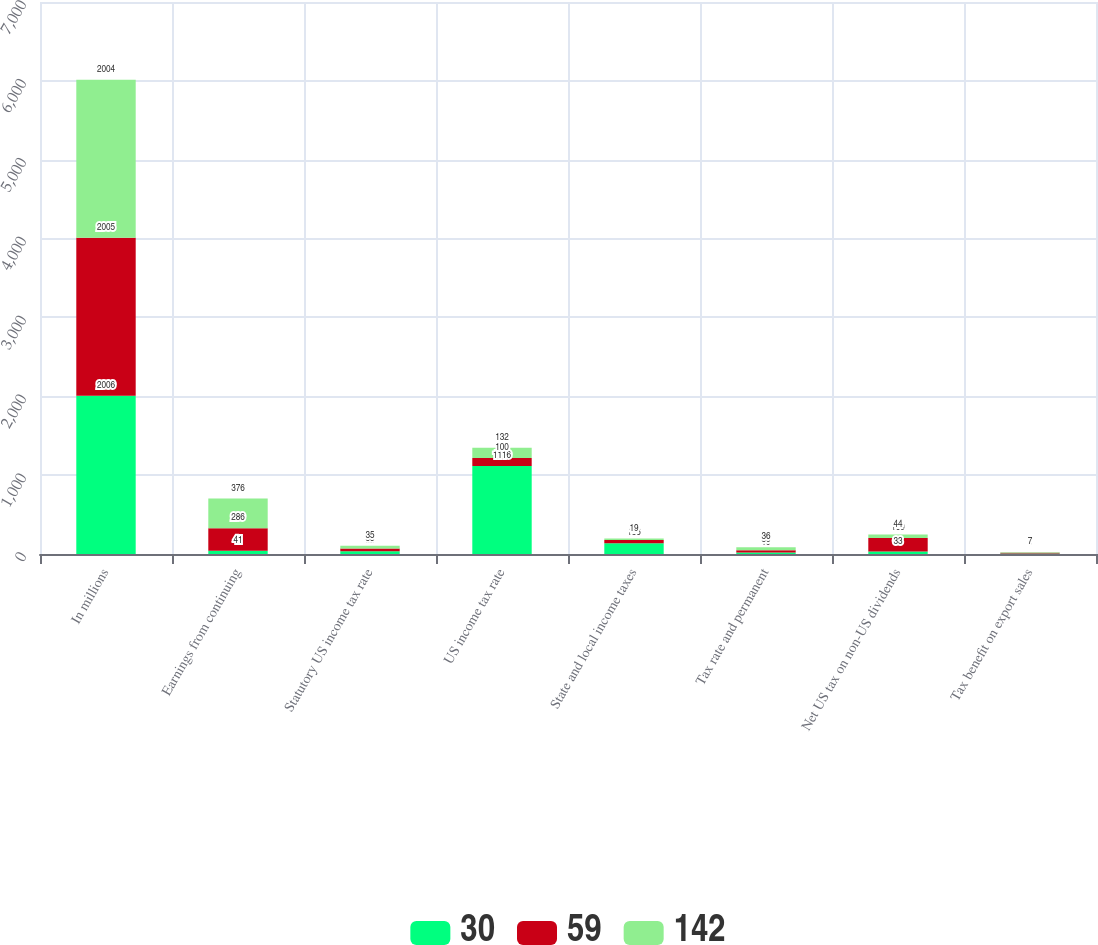Convert chart. <chart><loc_0><loc_0><loc_500><loc_500><stacked_bar_chart><ecel><fcel>In millions<fcel>Earnings from continuing<fcel>Statutory US income tax rate<fcel>US income tax rate<fcel>State and local income taxes<fcel>Tax rate and permanent<fcel>Net US tax on non-US dividends<fcel>Tax benefit on export sales<nl><fcel>30<fcel>2006<fcel>41<fcel>35<fcel>1116<fcel>136<fcel>19<fcel>33<fcel>6<nl><fcel>59<fcel>2005<fcel>286<fcel>35<fcel>100<fcel>41<fcel>30<fcel>169<fcel>9<nl><fcel>142<fcel>2004<fcel>376<fcel>35<fcel>132<fcel>19<fcel>36<fcel>44<fcel>7<nl></chart> 